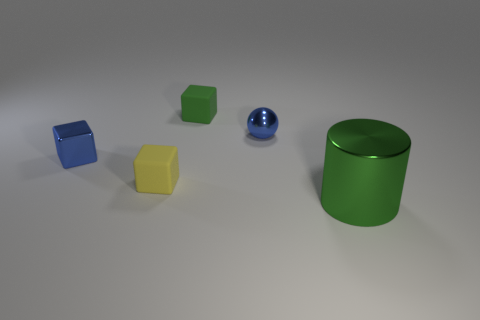Is there a metal block in front of the tiny blue object behind the metallic block?
Your response must be concise. Yes. Are there the same number of tiny blue metal balls behind the ball and tiny blue balls?
Offer a very short reply. No. How many other objects are the same size as the yellow object?
Your answer should be compact. 3. Is the green thing on the right side of the blue ball made of the same material as the small cube on the right side of the tiny yellow rubber thing?
Your answer should be very brief. No. There is a green thing in front of the green thing behind the large green cylinder; how big is it?
Give a very brief answer. Large. Are there any other objects that have the same color as the large object?
Provide a succinct answer. Yes. There is a small matte thing to the left of the small green matte thing; is its color the same as the tiny metal thing that is on the left side of the small green cube?
Provide a short and direct response. No. What shape is the big object?
Offer a very short reply. Cylinder. There is a big cylinder; what number of green shiny cylinders are behind it?
Offer a very short reply. 0. What number of small yellow cylinders have the same material as the large green object?
Ensure brevity in your answer.  0. 